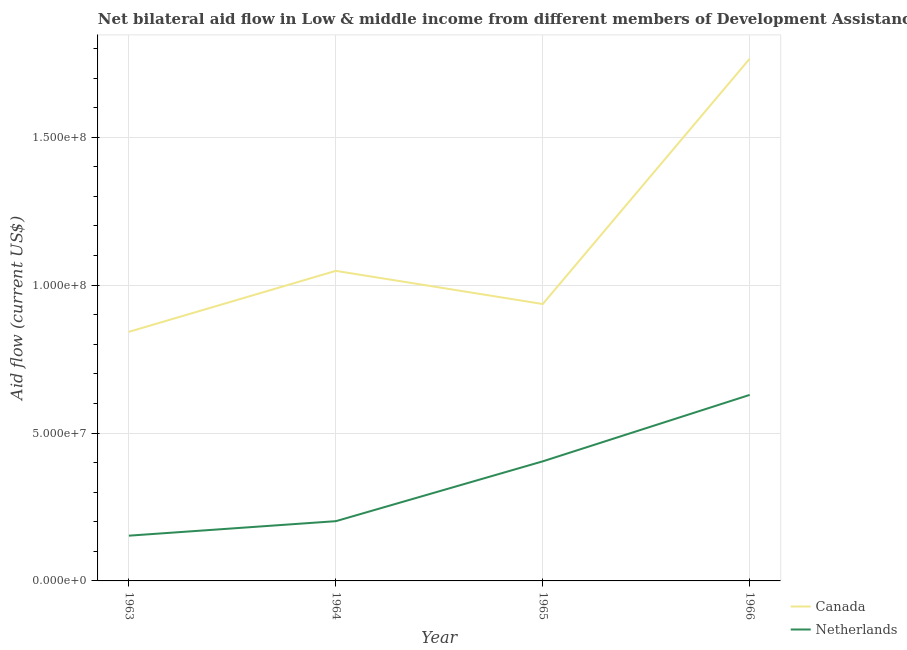How many different coloured lines are there?
Give a very brief answer. 2. What is the amount of aid given by netherlands in 1964?
Your answer should be compact. 2.02e+07. Across all years, what is the maximum amount of aid given by netherlands?
Keep it short and to the point. 6.29e+07. Across all years, what is the minimum amount of aid given by canada?
Make the answer very short. 8.42e+07. In which year was the amount of aid given by netherlands maximum?
Make the answer very short. 1966. In which year was the amount of aid given by netherlands minimum?
Offer a terse response. 1963. What is the total amount of aid given by netherlands in the graph?
Your response must be concise. 1.39e+08. What is the difference between the amount of aid given by canada in 1963 and that in 1966?
Provide a short and direct response. -9.23e+07. What is the difference between the amount of aid given by netherlands in 1964 and the amount of aid given by canada in 1963?
Ensure brevity in your answer.  -6.40e+07. What is the average amount of aid given by canada per year?
Give a very brief answer. 1.15e+08. In the year 1965, what is the difference between the amount of aid given by netherlands and amount of aid given by canada?
Offer a very short reply. -5.32e+07. What is the ratio of the amount of aid given by netherlands in 1964 to that in 1965?
Offer a terse response. 0.5. What is the difference between the highest and the second highest amount of aid given by netherlands?
Offer a very short reply. 2.25e+07. What is the difference between the highest and the lowest amount of aid given by canada?
Offer a very short reply. 9.23e+07. In how many years, is the amount of aid given by canada greater than the average amount of aid given by canada taken over all years?
Make the answer very short. 1. Is the amount of aid given by canada strictly greater than the amount of aid given by netherlands over the years?
Provide a succinct answer. Yes. How many lines are there?
Your answer should be compact. 2. Are the values on the major ticks of Y-axis written in scientific E-notation?
Offer a very short reply. Yes. How many legend labels are there?
Your answer should be very brief. 2. How are the legend labels stacked?
Your answer should be compact. Vertical. What is the title of the graph?
Your answer should be compact. Net bilateral aid flow in Low & middle income from different members of Development Assistance Committee. Does "Total Population" appear as one of the legend labels in the graph?
Offer a terse response. No. What is the Aid flow (current US$) in Canada in 1963?
Make the answer very short. 8.42e+07. What is the Aid flow (current US$) in Netherlands in 1963?
Your answer should be compact. 1.53e+07. What is the Aid flow (current US$) of Canada in 1964?
Keep it short and to the point. 1.05e+08. What is the Aid flow (current US$) in Netherlands in 1964?
Your response must be concise. 2.02e+07. What is the Aid flow (current US$) in Canada in 1965?
Provide a short and direct response. 9.36e+07. What is the Aid flow (current US$) in Netherlands in 1965?
Your response must be concise. 4.04e+07. What is the Aid flow (current US$) in Canada in 1966?
Offer a very short reply. 1.77e+08. What is the Aid flow (current US$) in Netherlands in 1966?
Offer a terse response. 6.29e+07. Across all years, what is the maximum Aid flow (current US$) in Canada?
Provide a succinct answer. 1.77e+08. Across all years, what is the maximum Aid flow (current US$) of Netherlands?
Offer a very short reply. 6.29e+07. Across all years, what is the minimum Aid flow (current US$) of Canada?
Offer a very short reply. 8.42e+07. Across all years, what is the minimum Aid flow (current US$) of Netherlands?
Your response must be concise. 1.53e+07. What is the total Aid flow (current US$) in Canada in the graph?
Your response must be concise. 4.59e+08. What is the total Aid flow (current US$) of Netherlands in the graph?
Provide a succinct answer. 1.39e+08. What is the difference between the Aid flow (current US$) of Canada in 1963 and that in 1964?
Your response must be concise. -2.06e+07. What is the difference between the Aid flow (current US$) in Netherlands in 1963 and that in 1964?
Offer a very short reply. -4.90e+06. What is the difference between the Aid flow (current US$) in Canada in 1963 and that in 1965?
Make the answer very short. -9.40e+06. What is the difference between the Aid flow (current US$) in Netherlands in 1963 and that in 1965?
Offer a terse response. -2.51e+07. What is the difference between the Aid flow (current US$) of Canada in 1963 and that in 1966?
Provide a succinct answer. -9.23e+07. What is the difference between the Aid flow (current US$) of Netherlands in 1963 and that in 1966?
Make the answer very short. -4.76e+07. What is the difference between the Aid flow (current US$) of Canada in 1964 and that in 1965?
Ensure brevity in your answer.  1.12e+07. What is the difference between the Aid flow (current US$) of Netherlands in 1964 and that in 1965?
Give a very brief answer. -2.02e+07. What is the difference between the Aid flow (current US$) in Canada in 1964 and that in 1966?
Make the answer very short. -7.17e+07. What is the difference between the Aid flow (current US$) of Netherlands in 1964 and that in 1966?
Offer a very short reply. -4.27e+07. What is the difference between the Aid flow (current US$) in Canada in 1965 and that in 1966?
Your answer should be very brief. -8.29e+07. What is the difference between the Aid flow (current US$) in Netherlands in 1965 and that in 1966?
Your answer should be very brief. -2.25e+07. What is the difference between the Aid flow (current US$) of Canada in 1963 and the Aid flow (current US$) of Netherlands in 1964?
Your answer should be very brief. 6.40e+07. What is the difference between the Aid flow (current US$) in Canada in 1963 and the Aid flow (current US$) in Netherlands in 1965?
Your answer should be very brief. 4.38e+07. What is the difference between the Aid flow (current US$) in Canada in 1963 and the Aid flow (current US$) in Netherlands in 1966?
Your response must be concise. 2.13e+07. What is the difference between the Aid flow (current US$) in Canada in 1964 and the Aid flow (current US$) in Netherlands in 1965?
Ensure brevity in your answer.  6.44e+07. What is the difference between the Aid flow (current US$) of Canada in 1964 and the Aid flow (current US$) of Netherlands in 1966?
Offer a very short reply. 4.19e+07. What is the difference between the Aid flow (current US$) of Canada in 1965 and the Aid flow (current US$) of Netherlands in 1966?
Offer a very short reply. 3.07e+07. What is the average Aid flow (current US$) of Canada per year?
Provide a succinct answer. 1.15e+08. What is the average Aid flow (current US$) in Netherlands per year?
Make the answer very short. 3.47e+07. In the year 1963, what is the difference between the Aid flow (current US$) in Canada and Aid flow (current US$) in Netherlands?
Keep it short and to the point. 6.89e+07. In the year 1964, what is the difference between the Aid flow (current US$) of Canada and Aid flow (current US$) of Netherlands?
Keep it short and to the point. 8.46e+07. In the year 1965, what is the difference between the Aid flow (current US$) of Canada and Aid flow (current US$) of Netherlands?
Your response must be concise. 5.32e+07. In the year 1966, what is the difference between the Aid flow (current US$) of Canada and Aid flow (current US$) of Netherlands?
Your response must be concise. 1.14e+08. What is the ratio of the Aid flow (current US$) of Canada in 1963 to that in 1964?
Your answer should be compact. 0.8. What is the ratio of the Aid flow (current US$) in Netherlands in 1963 to that in 1964?
Your answer should be compact. 0.76. What is the ratio of the Aid flow (current US$) in Canada in 1963 to that in 1965?
Your response must be concise. 0.9. What is the ratio of the Aid flow (current US$) of Netherlands in 1963 to that in 1965?
Provide a succinct answer. 0.38. What is the ratio of the Aid flow (current US$) in Canada in 1963 to that in 1966?
Provide a short and direct response. 0.48. What is the ratio of the Aid flow (current US$) of Netherlands in 1963 to that in 1966?
Provide a succinct answer. 0.24. What is the ratio of the Aid flow (current US$) in Canada in 1964 to that in 1965?
Offer a very short reply. 1.12. What is the ratio of the Aid flow (current US$) in Netherlands in 1964 to that in 1965?
Make the answer very short. 0.5. What is the ratio of the Aid flow (current US$) in Canada in 1964 to that in 1966?
Provide a succinct answer. 0.59. What is the ratio of the Aid flow (current US$) of Netherlands in 1964 to that in 1966?
Ensure brevity in your answer.  0.32. What is the ratio of the Aid flow (current US$) in Canada in 1965 to that in 1966?
Provide a succinct answer. 0.53. What is the ratio of the Aid flow (current US$) of Netherlands in 1965 to that in 1966?
Offer a terse response. 0.64. What is the difference between the highest and the second highest Aid flow (current US$) in Canada?
Provide a succinct answer. 7.17e+07. What is the difference between the highest and the second highest Aid flow (current US$) in Netherlands?
Provide a succinct answer. 2.25e+07. What is the difference between the highest and the lowest Aid flow (current US$) of Canada?
Make the answer very short. 9.23e+07. What is the difference between the highest and the lowest Aid flow (current US$) of Netherlands?
Provide a succinct answer. 4.76e+07. 